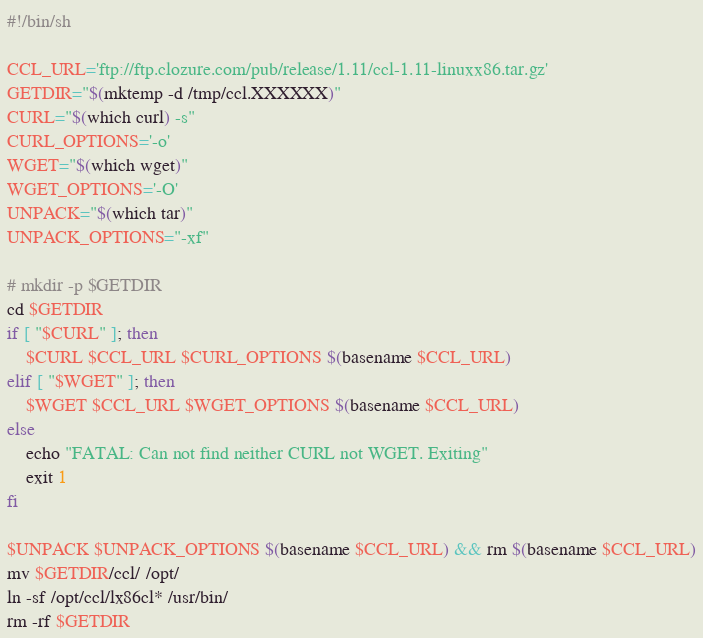<code> <loc_0><loc_0><loc_500><loc_500><_Bash_>#!/bin/sh

CCL_URL='ftp://ftp.clozure.com/pub/release/1.11/ccl-1.11-linuxx86.tar.gz'
GETDIR="$(mktemp -d /tmp/ccl.XXXXXX)"
CURL="$(which curl) -s"
CURL_OPTIONS='-o'
WGET="$(which wget)"
WGET_OPTIONS='-O'
UNPACK="$(which tar)"
UNPACK_OPTIONS="-xf"

# mkdir -p $GETDIR
cd $GETDIR
if [ "$CURL" ]; then
    $CURL $CCL_URL $CURL_OPTIONS $(basename $CCL_URL)
elif [ "$WGET" ]; then
    $WGET $CCL_URL $WGET_OPTIONS $(basename $CCL_URL)
else
    echo "FATAL: Can not find neither CURL not WGET. Exiting"
    exit 1
fi

$UNPACK $UNPACK_OPTIONS $(basename $CCL_URL) && rm $(basename $CCL_URL)
mv $GETDIR/ccl/ /opt/
ln -sf /opt/ccl/lx86cl* /usr/bin/
rm -rf $GETDIR
</code> 